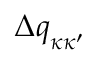Convert formula to latex. <formula><loc_0><loc_0><loc_500><loc_500>\Delta q _ { \kappa \kappa ^ { \prime } }</formula> 